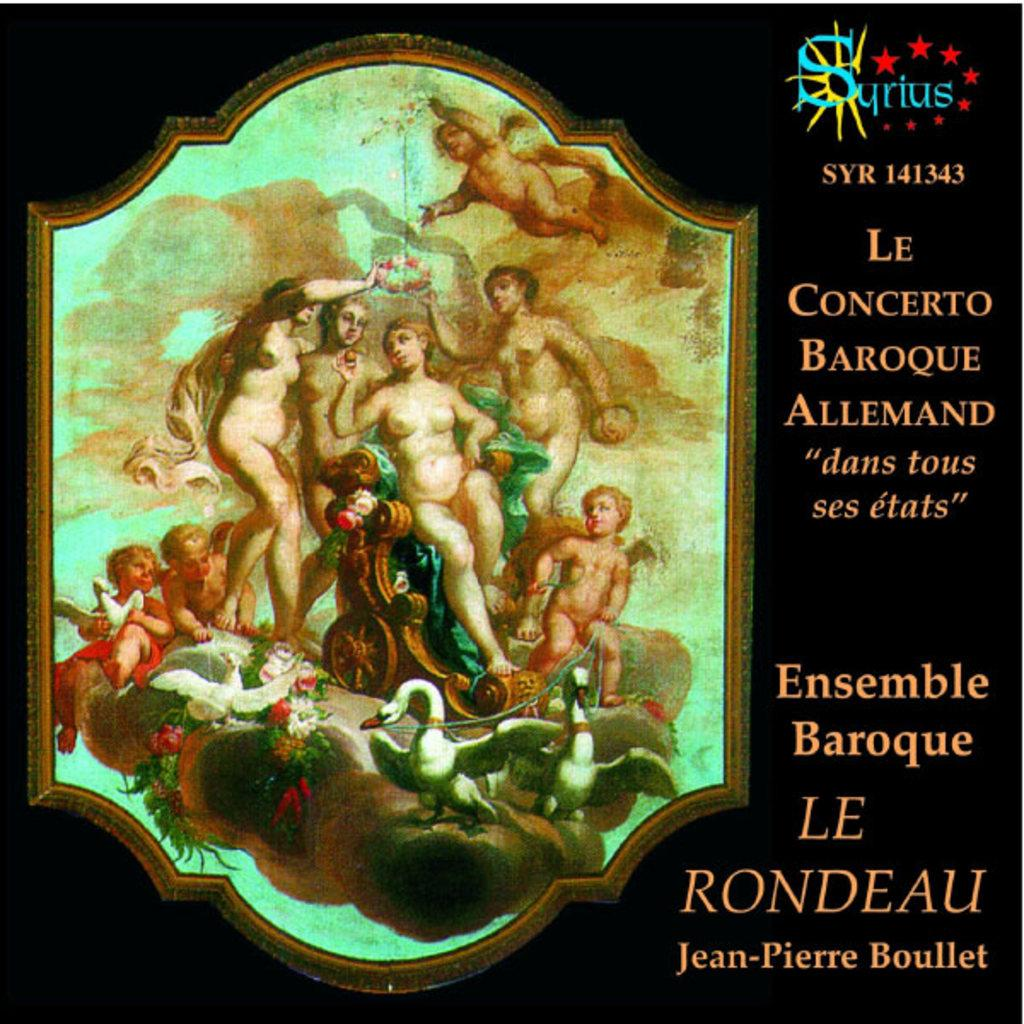What is the main subject of the image? The main subject of the image is a cover photo. What is depicted in the cover photo? The cover photo contains a painting of some persons. Are there any other elements in the image besides the cover photo? Yes, there is text and a logo in the image. Can you see any ornaments hanging from the painting in the image? There are no ornaments visible in the image; it features a cover photo with a painting of some persons, text, and a logo. Is there a nest visible in the image? There is no nest present in the image. 